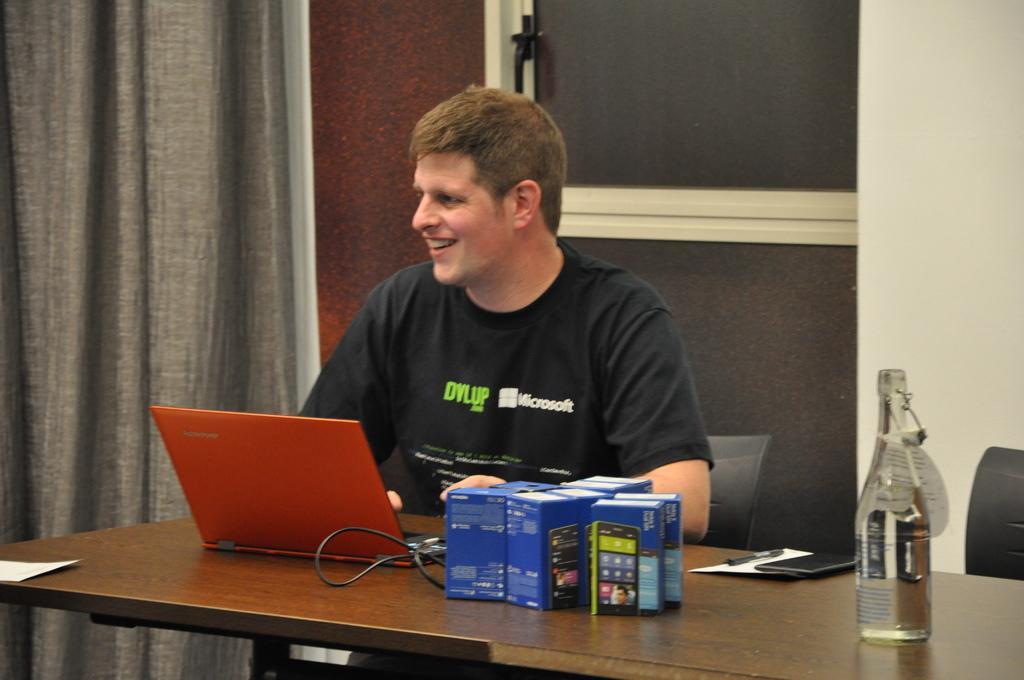Could you give a brief overview of what you see in this image? In this image there is a man sitting on chair at the table. On the table there is a water bottle, boxes, a laptop, paper and a cable wire. Behind him there is a wall, door and curtain. 